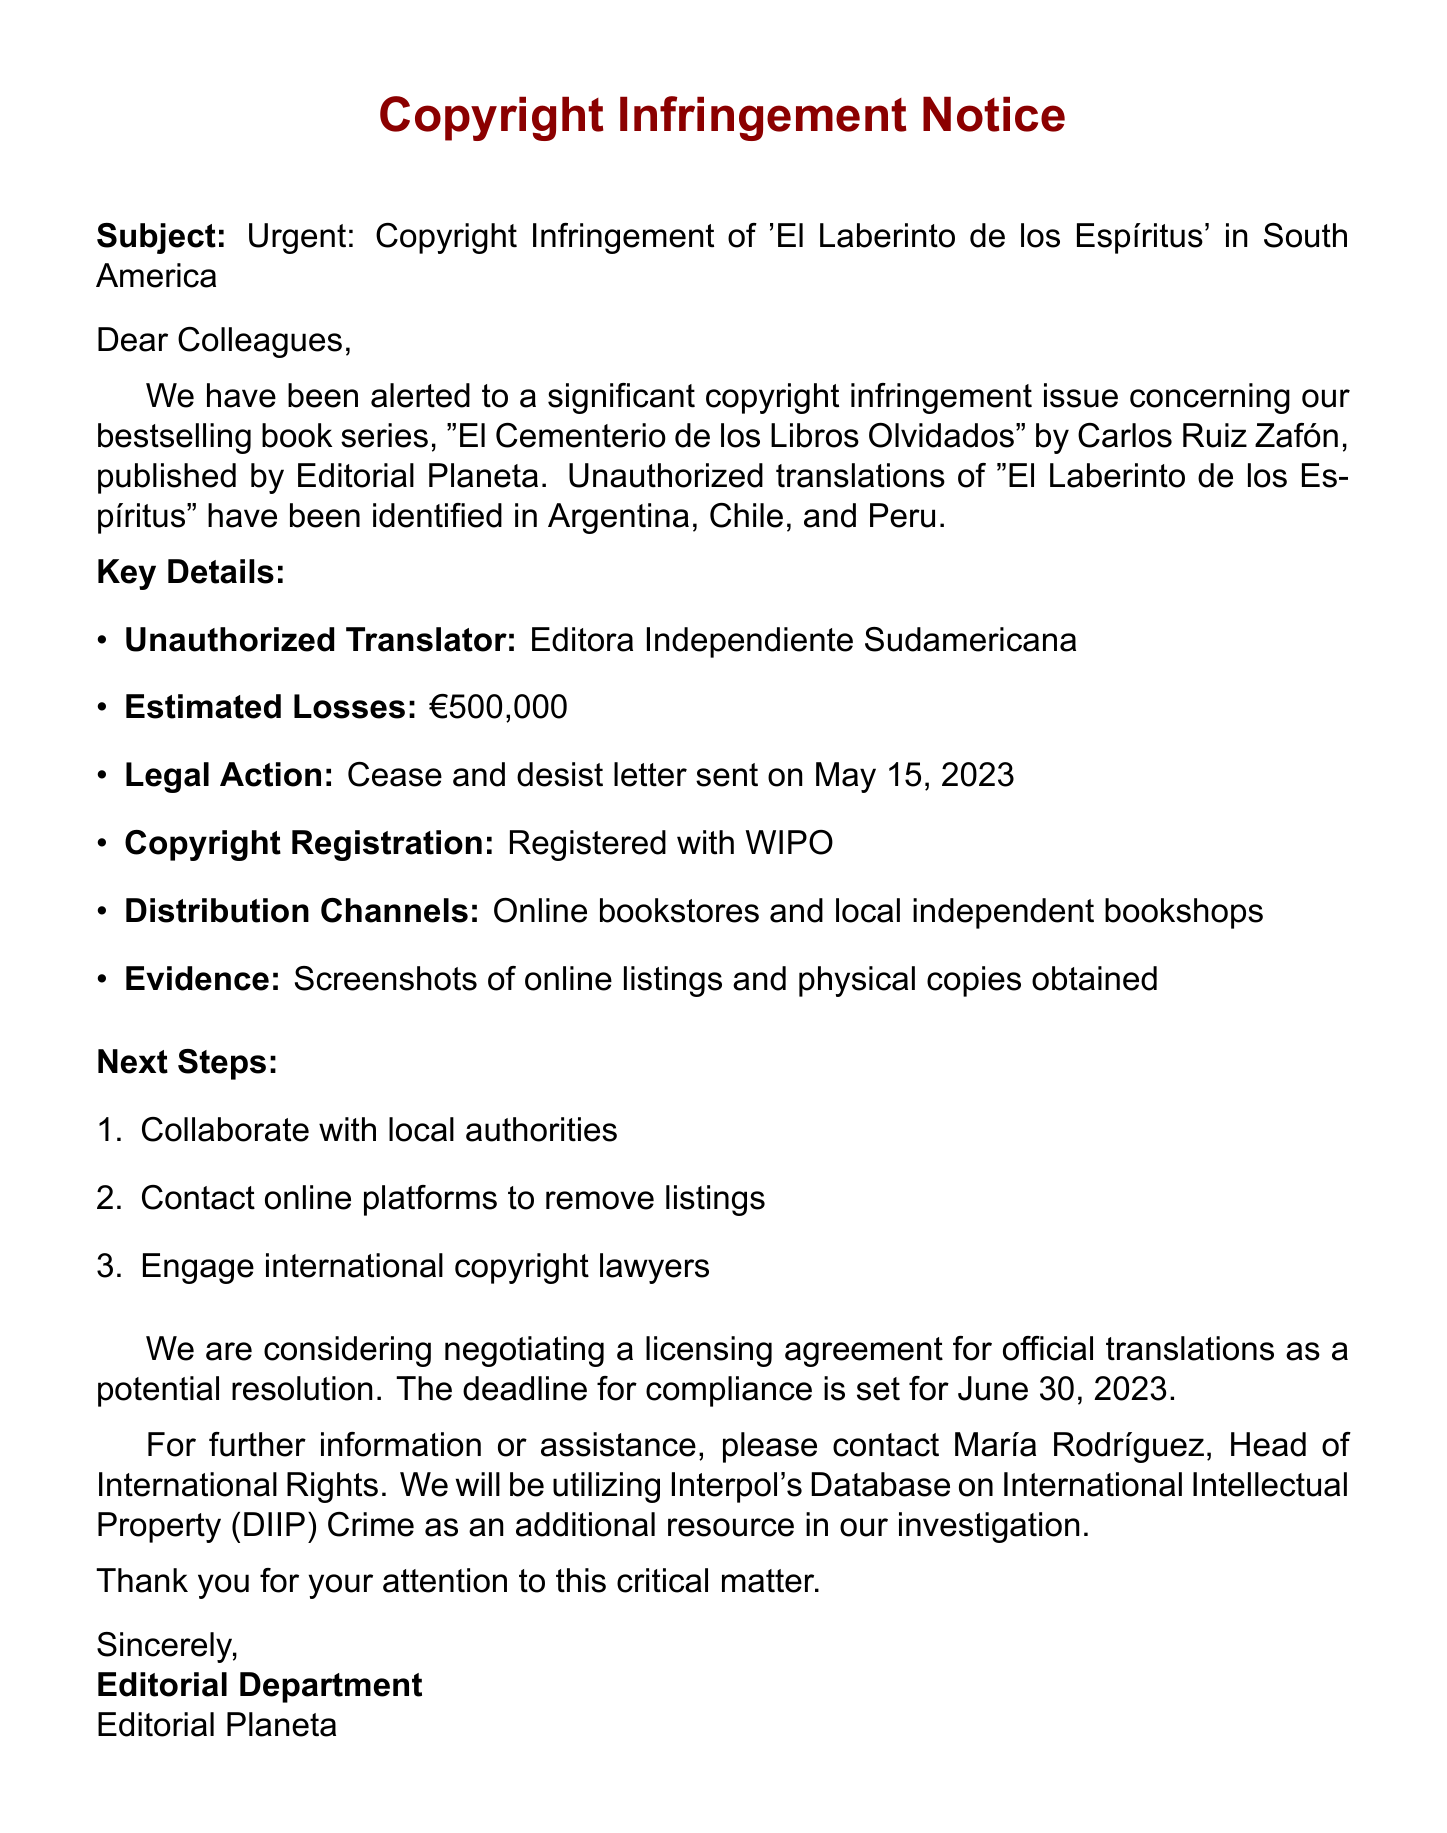What is the subject of the email? The subject is stated at the beginning of the document and highlights the urgent nature of the copyright infringement issue.
Answer: Urgent: Copyright Infringement of 'El Laberinto de los Espíritus' in South America Who is the unauthorized translator? The document lists Editora Independiente Sudamericana as the entity responsible for the unauthorized translations.
Answer: Editora Independiente Sudamericana What are the infringing countries mentioned? The document specifies the countries where the infringement has been identified, which are detailed in a list format.
Answer: Argentina, Chile, Peru When was the cease and desist letter sent? The document provides a specific date for when the legal action was taken against the unauthorized translation.
Answer: May 15, 2023 What is the estimated loss mentioned? The document quantifies the financial impact of the copyright infringement.
Answer: €500,000 What is the deadline for compliance? The document mentions a specific date by which compliance with the cease and desist notice is expected.
Answer: June 30, 2023 What next steps are suggested in the document? The document lists a series of actions to be taken in response to the copyright infringement.
Answer: Collaborate with local authorities, Contact online platforms to remove listings, Engage international copyright lawyers Who should be contacted for further assistance? The document identifies a specific person who is in charge of handling international rights and can provide additional assistance.
Answer: María Rodríguez, Head of International Rights 